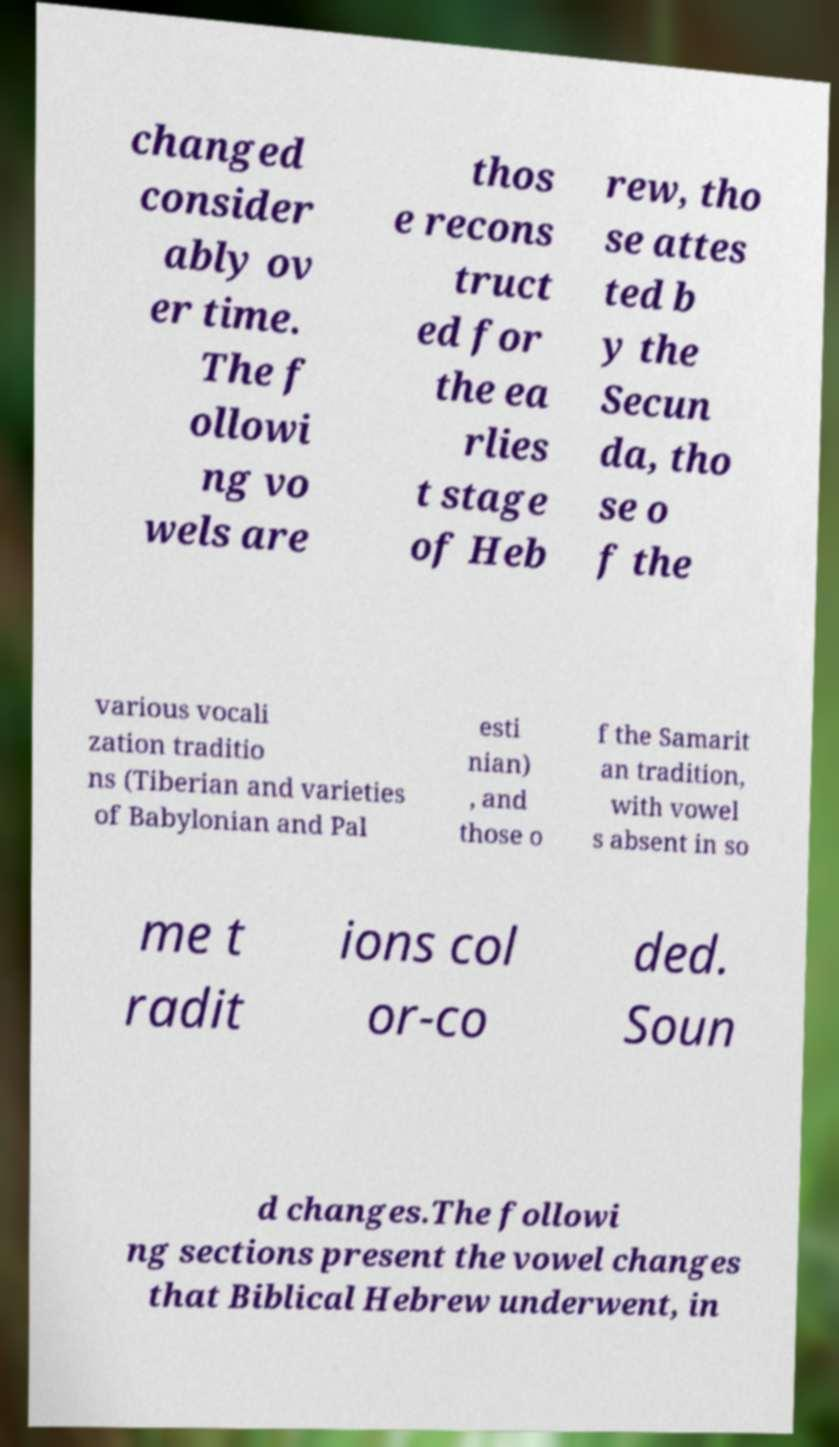Can you read and provide the text displayed in the image?This photo seems to have some interesting text. Can you extract and type it out for me? changed consider ably ov er time. The f ollowi ng vo wels are thos e recons truct ed for the ea rlies t stage of Heb rew, tho se attes ted b y the Secun da, tho se o f the various vocali zation traditio ns (Tiberian and varieties of Babylonian and Pal esti nian) , and those o f the Samarit an tradition, with vowel s absent in so me t radit ions col or-co ded. Soun d changes.The followi ng sections present the vowel changes that Biblical Hebrew underwent, in 